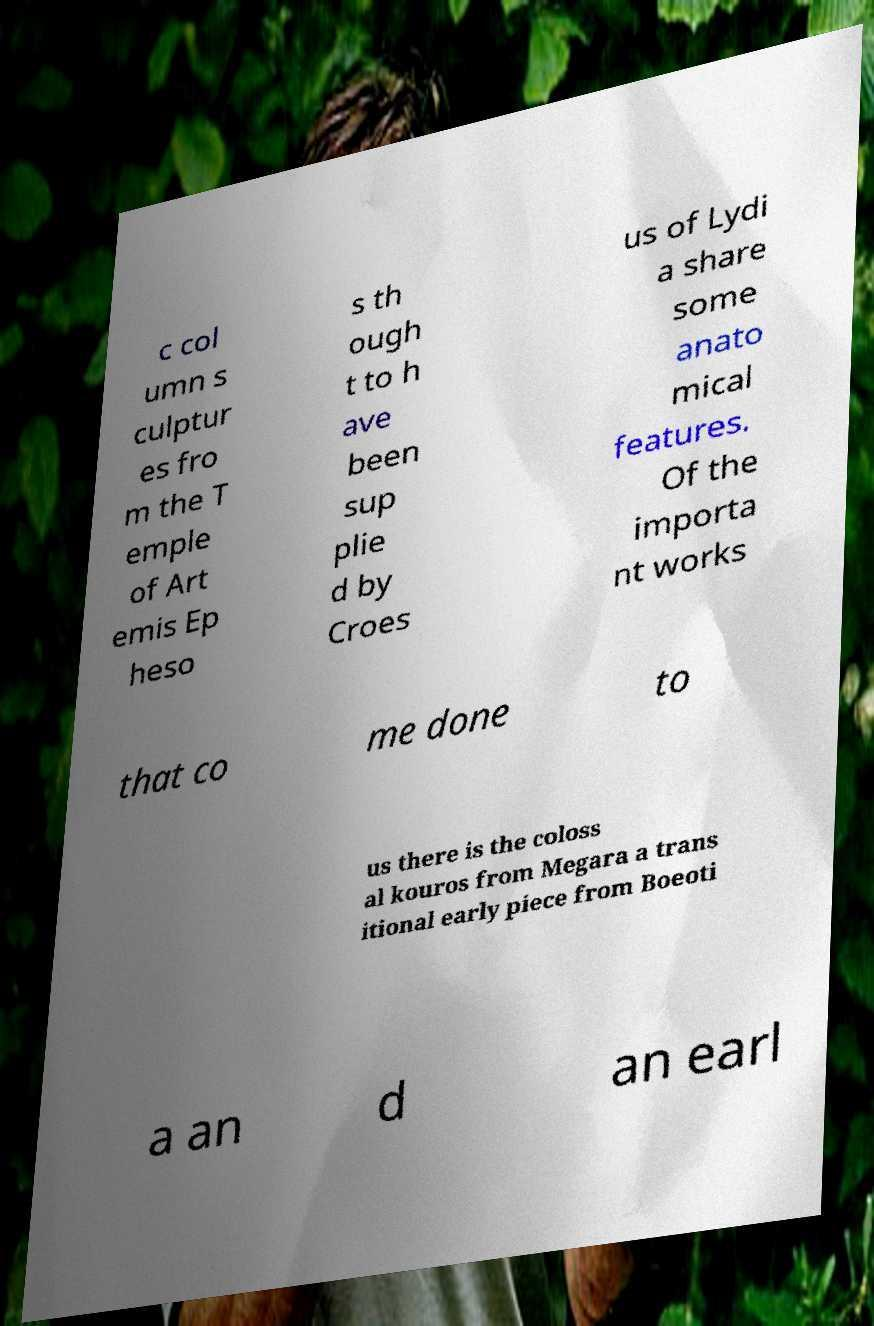For documentation purposes, I need the text within this image transcribed. Could you provide that? c col umn s culptur es fro m the T emple of Art emis Ep heso s th ough t to h ave been sup plie d by Croes us of Lydi a share some anato mical features. Of the importa nt works that co me done to us there is the coloss al kouros from Megara a trans itional early piece from Boeoti a an d an earl 